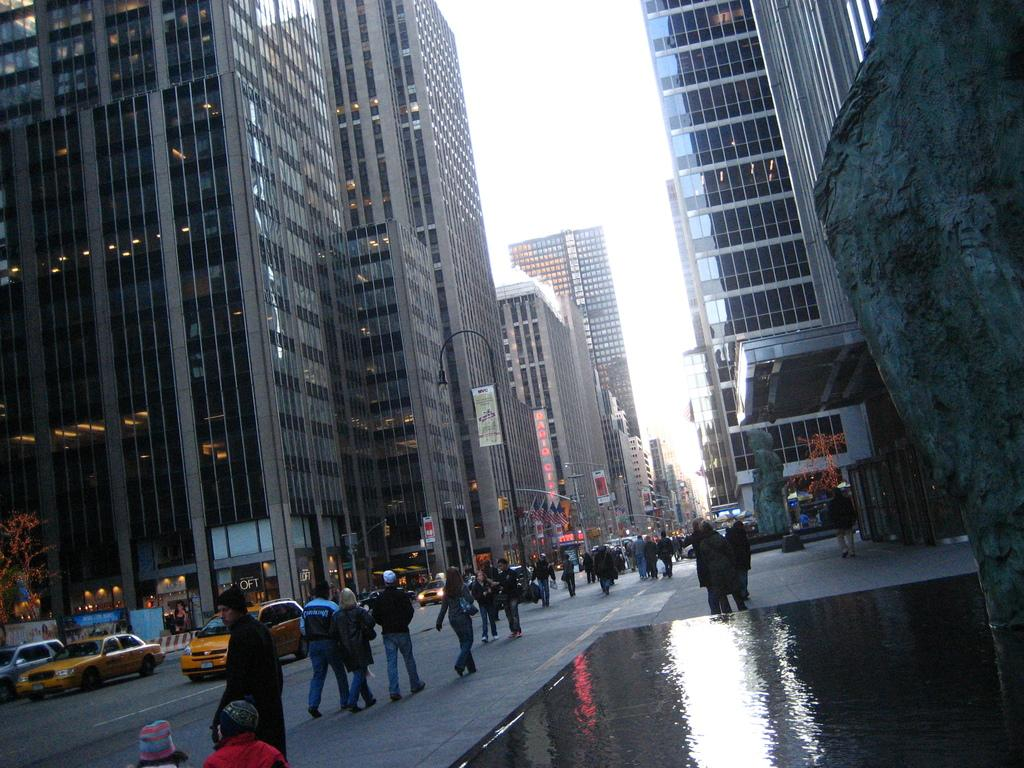What are the people in the image doing? The people in the image are walking on the road. What else can be seen on the road besides people? There are vehicles on the road. What can be seen in the background around the road? There are buildings and trees visible around the road. What type of cough medicine is being advertised on the billboard in the image? There is no billboard or advertisement for cough medicine present in the image. 